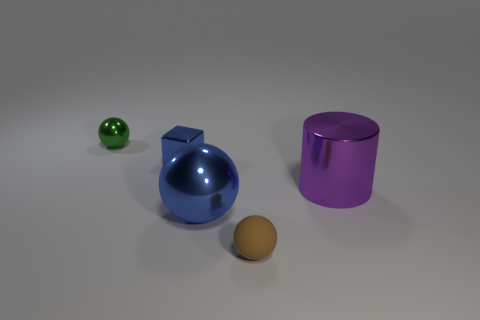Add 5 metal balls. How many objects exist? 10 Subtract all balls. How many objects are left? 2 Subtract all tiny purple rubber balls. Subtract all tiny metal cubes. How many objects are left? 4 Add 1 small metallic cubes. How many small metallic cubes are left? 2 Add 2 big purple metal objects. How many big purple metal objects exist? 3 Subtract 0 gray balls. How many objects are left? 5 